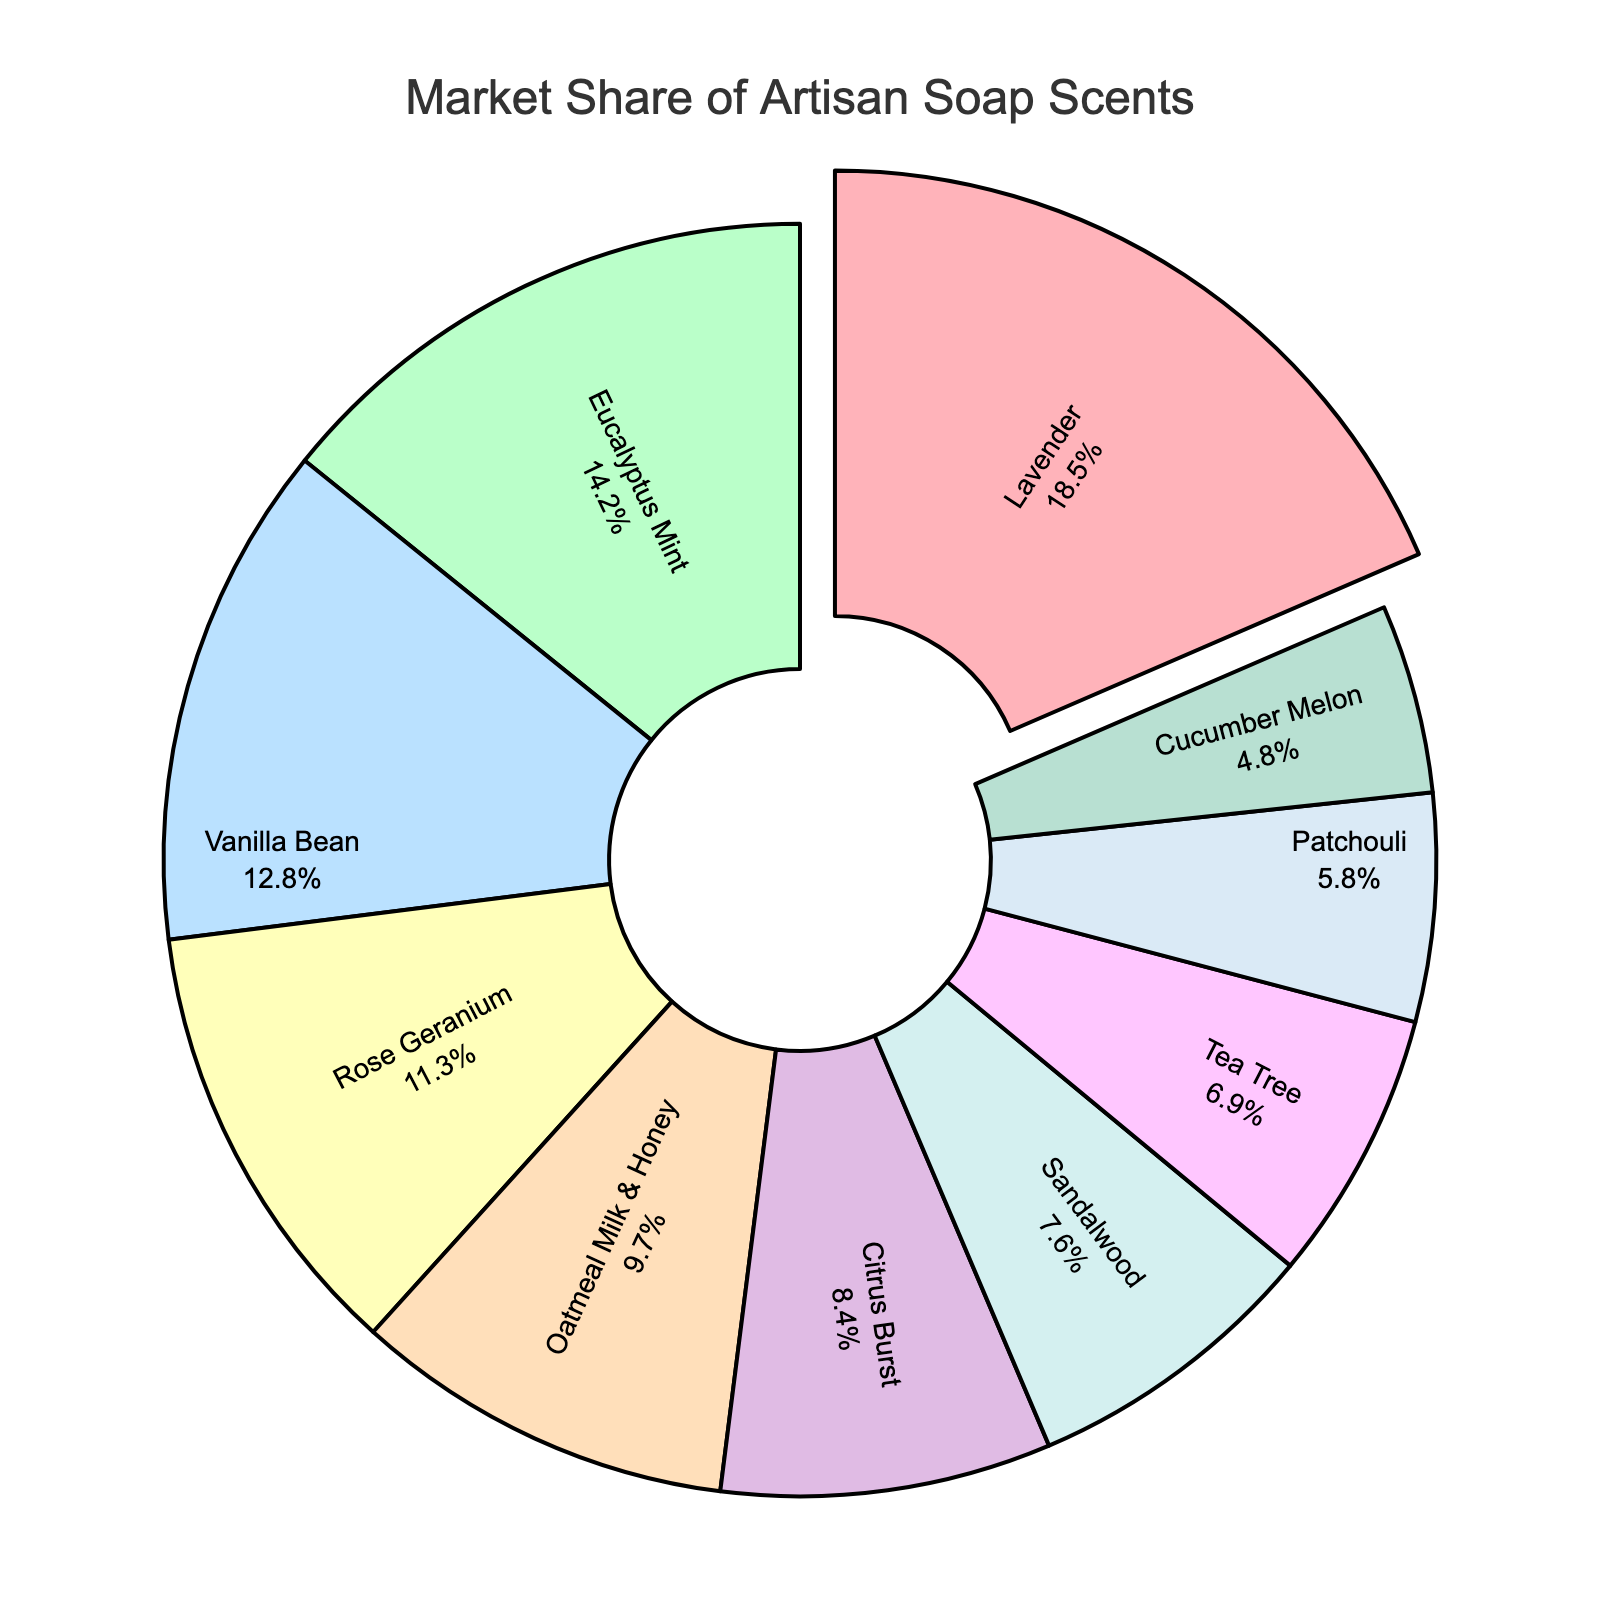What scent has the largest market share? The scent with the largest market share is indicated by the largest section of the pie chart.
Answer: Lavender Which scent has a greater market share, Eucalyptus Mint or Sandalwood? Compare the sizes of the Eucalyptus Mint and Sandalwood sections of the pie chart. Eucalyptus Mint has a larger section.
Answer: Eucalyptus Mint What is the combined market share of Vanilla Bean and Rose Geranium? Add the market shares of Vanilla Bean (12.8%) and Rose Geranium (11.3%). 12.8 + 11.3 = 24.1%
Answer: 24.1% Which scent has the smallest market share? The smallest section of the pie chart represents the scent with the smallest market share.
Answer: Cucumber Melon How much larger is the market share of Lavender compared to Patchouli? Subtract the market share of Patchouli (5.8%) from that of Lavender (18.5%). 18.5 - 5.8 = 12.7%
Answer: 12.7% Which two scents have the closest market share to each other? Compare the sections of the pie chart to find the two closest in size. Tea Tree (6.9%) and Patchouli (5.8%) are the closest.
Answer: Tea Tree and Patchouli What is the total market share of all scents that have more than 10% market share? Sum the market shares of Lavender (18.5%), Eucalyptus Mint (14.2%), Vanilla Bean (12.8%), and Rose Geranium (11.3%). 18.5 + 14.2 + 12.8 + 11.3 = 56.8%
Answer: 56.8% If we exclude the scent with the smallest market share, what is the new total market share? Subtract the smallest market share (Cucumber Melon, 4.8%) from 100%. 100 - 4.8 = 95.2%
Answer: 95.2% What percentage more market share does the scent with the most share have compared to the scent with the least share? Calculate the difference in market share between Lavender (18.5%) and Cucumber Melon (4.8%), then find the percentage. (18.5 - 4.8) / 4.8 * 100 = 285.4%
Answer: 285.4% What is the average market share of the scents with a market share less than 10%? Sum the market shares of Oatmeal Milk & Honey (9.7%), Citrus Burst (8.4%), Sandalwood (7.6%), Tea Tree (6.9%), Patchouli (5.8%), and Cucumber Melon (4.8%), then divide by 6. (9.7 + 8.4 + 7.6 + 6.9 + 5.8 + 4.8) / 6 = 7.2%
Answer: 7.2% 